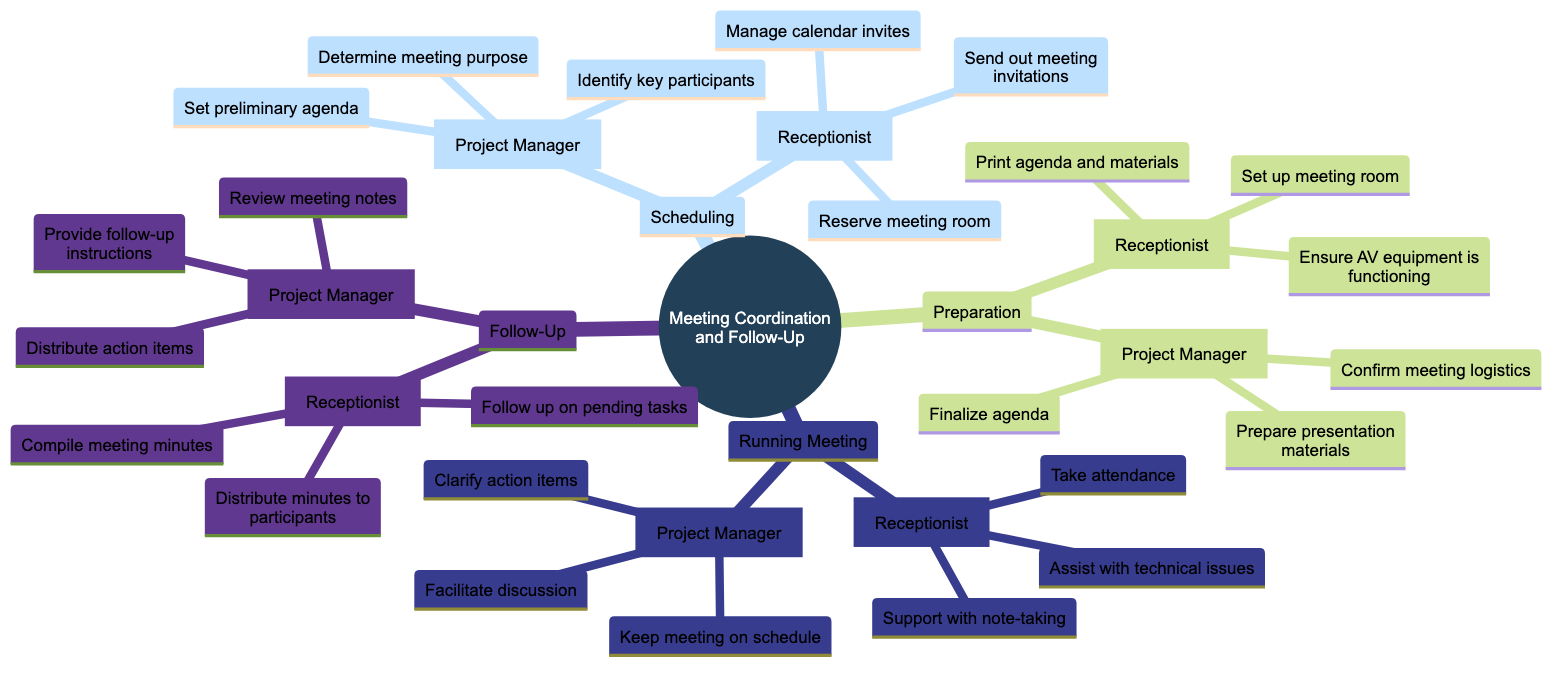What are the responsibilities of the Project Manager in the Follow-Up stage? The diagram indicates that in the Follow-Up stage, the Project Manager has three responsibilities listed under the "Project Manager" node: "Review meeting notes", "Distribute action items", and "Provide follow-up instructions".
Answer: Review meeting notes, Distribute action items, Provide follow-up instructions How many responsibilities does the Receptionist have in the Scheduling stage? By examining the "Scheduling" section of the diagram under the "Receptionist" node, we can see that there are three responsibilities: "Send out meeting invitations", "Manage calendar invites", and "Reserve meeting room". Therefore, the total is three responsibilities.
Answer: 3 What is the main role of the Receptionist during the Running Meeting phase? The diagram specifies the Receptionist's main roles in the Running Meeting phase, which are: "Take attendance", "Support with note-taking", and "Assist with technical issues". These signify that the Receptionist mainly supports the meeting logistics and documentation.
Answer: Take attendance, Support with note-taking, Assist with technical issues Which responsibilities are exclusive to the Project Manager in the Preparation stage? According to the diagram, the responsibilities in the Preparation stage that are exclusive to the Project Manager include: "Finalize agenda", "Prepare presentation materials", and "Confirm meeting logistics". These are not listed under the Receptionist's responsibilities in that stage.
Answer: Finalize agenda, Prepare presentation materials, Confirm meeting logistics How does the Receptionist contribute to meeting logistics? The Receptionist contributes to meeting logistics in the Preparation stage by printing agenda and materials, setting up the meeting room, and ensuring that AV equipment is functioning. Additionally, in the Scheduling stage, the Receptionist manages calendar invites and reserves the meeting room, further supporting logistics.
Answer: Printing agenda and materials, Setting up the meeting room, Ensuring AV equipment is functioning, Managing calendar invites, Reserving meeting room 